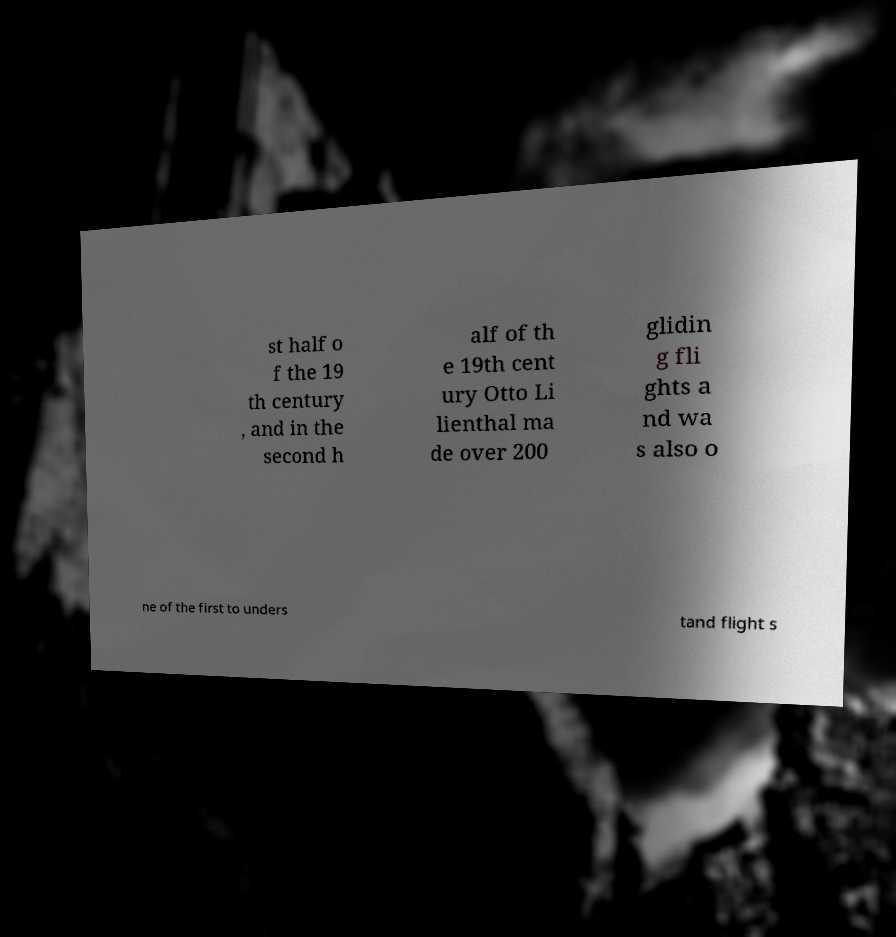Can you accurately transcribe the text from the provided image for me? st half o f the 19 th century , and in the second h alf of th e 19th cent ury Otto Li lienthal ma de over 200 glidin g fli ghts a nd wa s also o ne of the first to unders tand flight s 